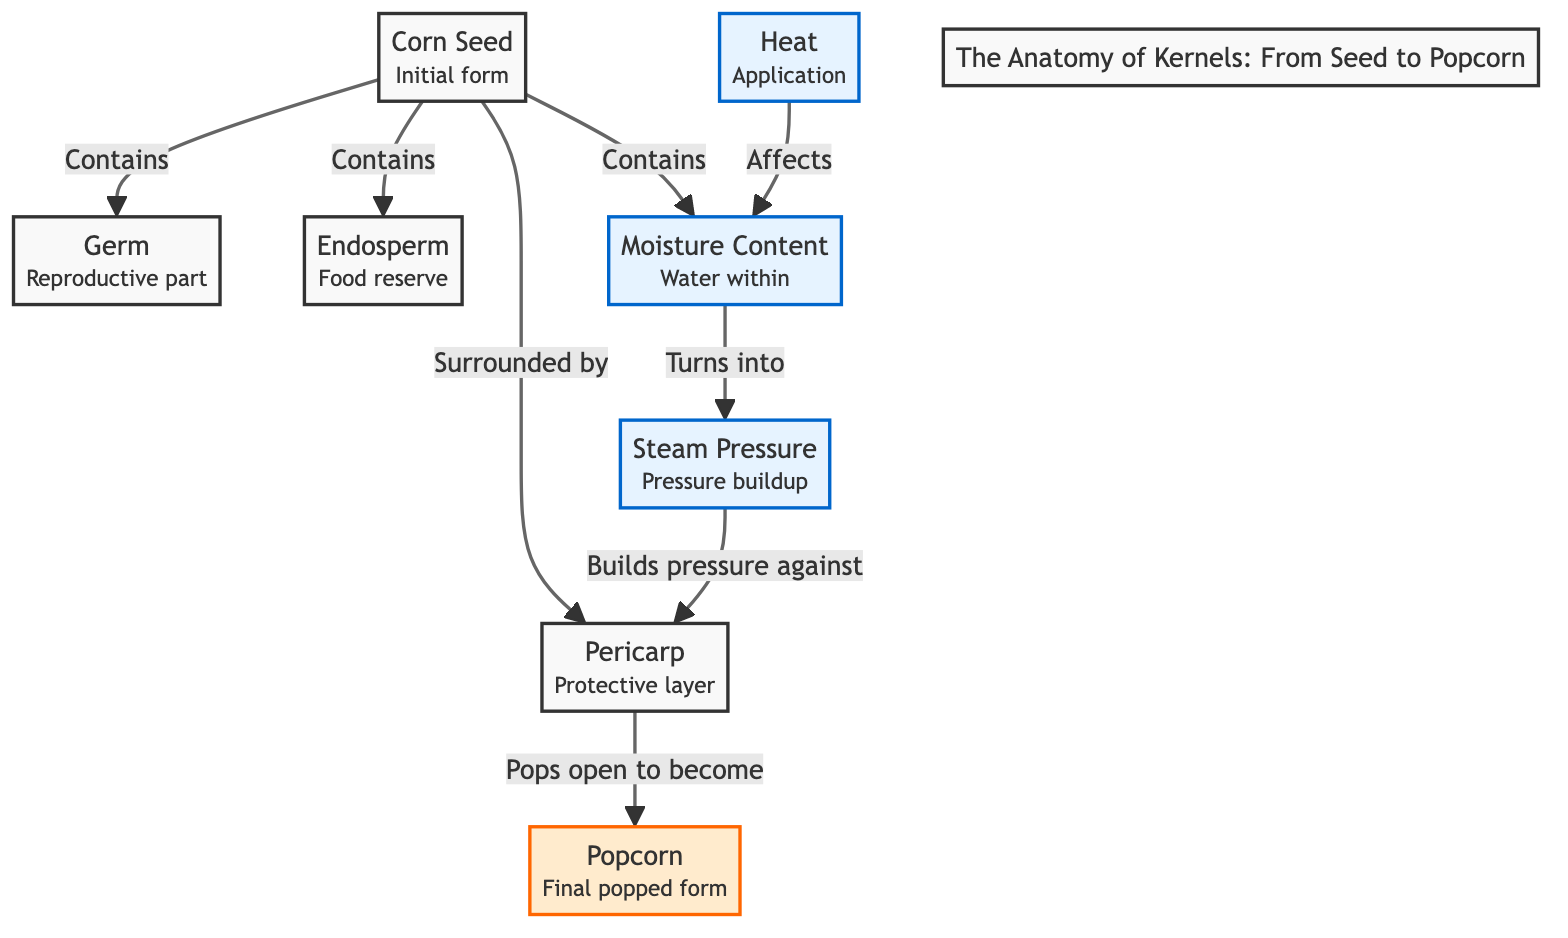What is the initial form of popcorn? The diagram starts with the "Corn Seed," which is identified as the initial form of popcorn. It is the first node in the sequence of the diagram.
Answer: Corn Seed How many primary components are contained in a corn seed? The corn seed contains three primary components according to the diagram: germ, endosperm, and moisture. These are explicitly mentioned as part of the seed's structure.
Answer: Three What does moisture turn into during the popping process? Based on the diagram, moisture is transformed into steam as a result of heat application. This transformation is indicated by the arrow leading from moisture to steam.
Answer: Steam What role does heat play in the process? Heat is noted in the diagram as affecting moisture, which is directly connected, indicating its influence in changing moisture into steam. This relationship defines the functional role of heat.
Answer: Affects moisture What happens to the pericarp during the popping process? The diagram illustrates that the pericarp pops open as a final action in the sequence, indicating its rupture due to pressure from steam. This is the process's concluding result.
Answer: Pops open What does steam pressure build against? The steam created from the moisture builds pressure against the pericarp, which is specifically stated in the diagram as the action that occurs after steam is generated.
Answer: Pericarp What is the final form of popcorn? The diagram concludes with the node labeled "Popcorn," indicating that this is the end result of the processes initiated from the seed. It is clearly marked as the final product.
Answer: Popcorn How does moisture enter the bubbling process? The process starts with moisture, which is contained within the corn seed. After heat affects the moisture, it turns into steam, illustrating the sequence of events from moisture to bubbling.
Answer: Turns into steam What surrounds the germ and endosperm in a corn seed? The pericarp acts as the protective layer surrounding the germ and endosperm, which is explicitly noted in the diagram's descriptions and connections.
Answer: Pericarp 